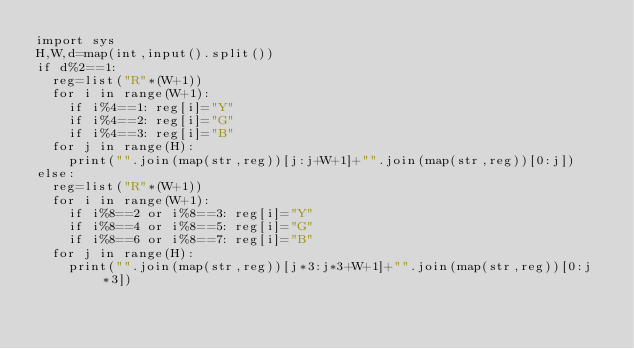<code> <loc_0><loc_0><loc_500><loc_500><_Python_>import sys
H,W,d=map(int,input().split())
if d%2==1:
  reg=list("R"*(W+1))
  for i in range(W+1):
    if i%4==1: reg[i]="Y"
    if i%4==2: reg[i]="G"
    if i%4==3: reg[i]="B"
  for j in range(H):
    print("".join(map(str,reg))[j:j+W+1]+"".join(map(str,reg))[0:j])
else:
  reg=list("R"*(W+1))
  for i in range(W+1):
    if i%8==2 or i%8==3: reg[i]="Y"
    if i%8==4 or i%8==5: reg[i]="G"
    if i%8==6 or i%8==7: reg[i]="B"
  for j in range(H):
    print("".join(map(str,reg))[j*3:j*3+W+1]+"".join(map(str,reg))[0:j*3])</code> 